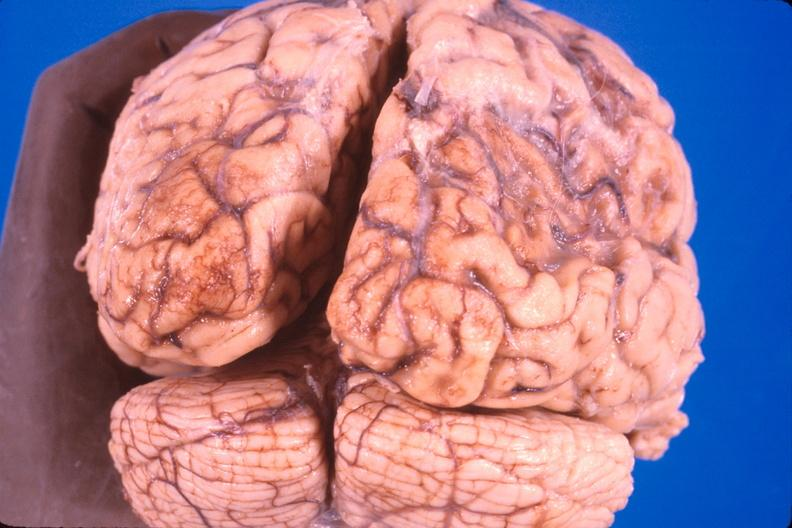does this image show brain, old infarcts, embolic?
Answer the question using a single word or phrase. Yes 